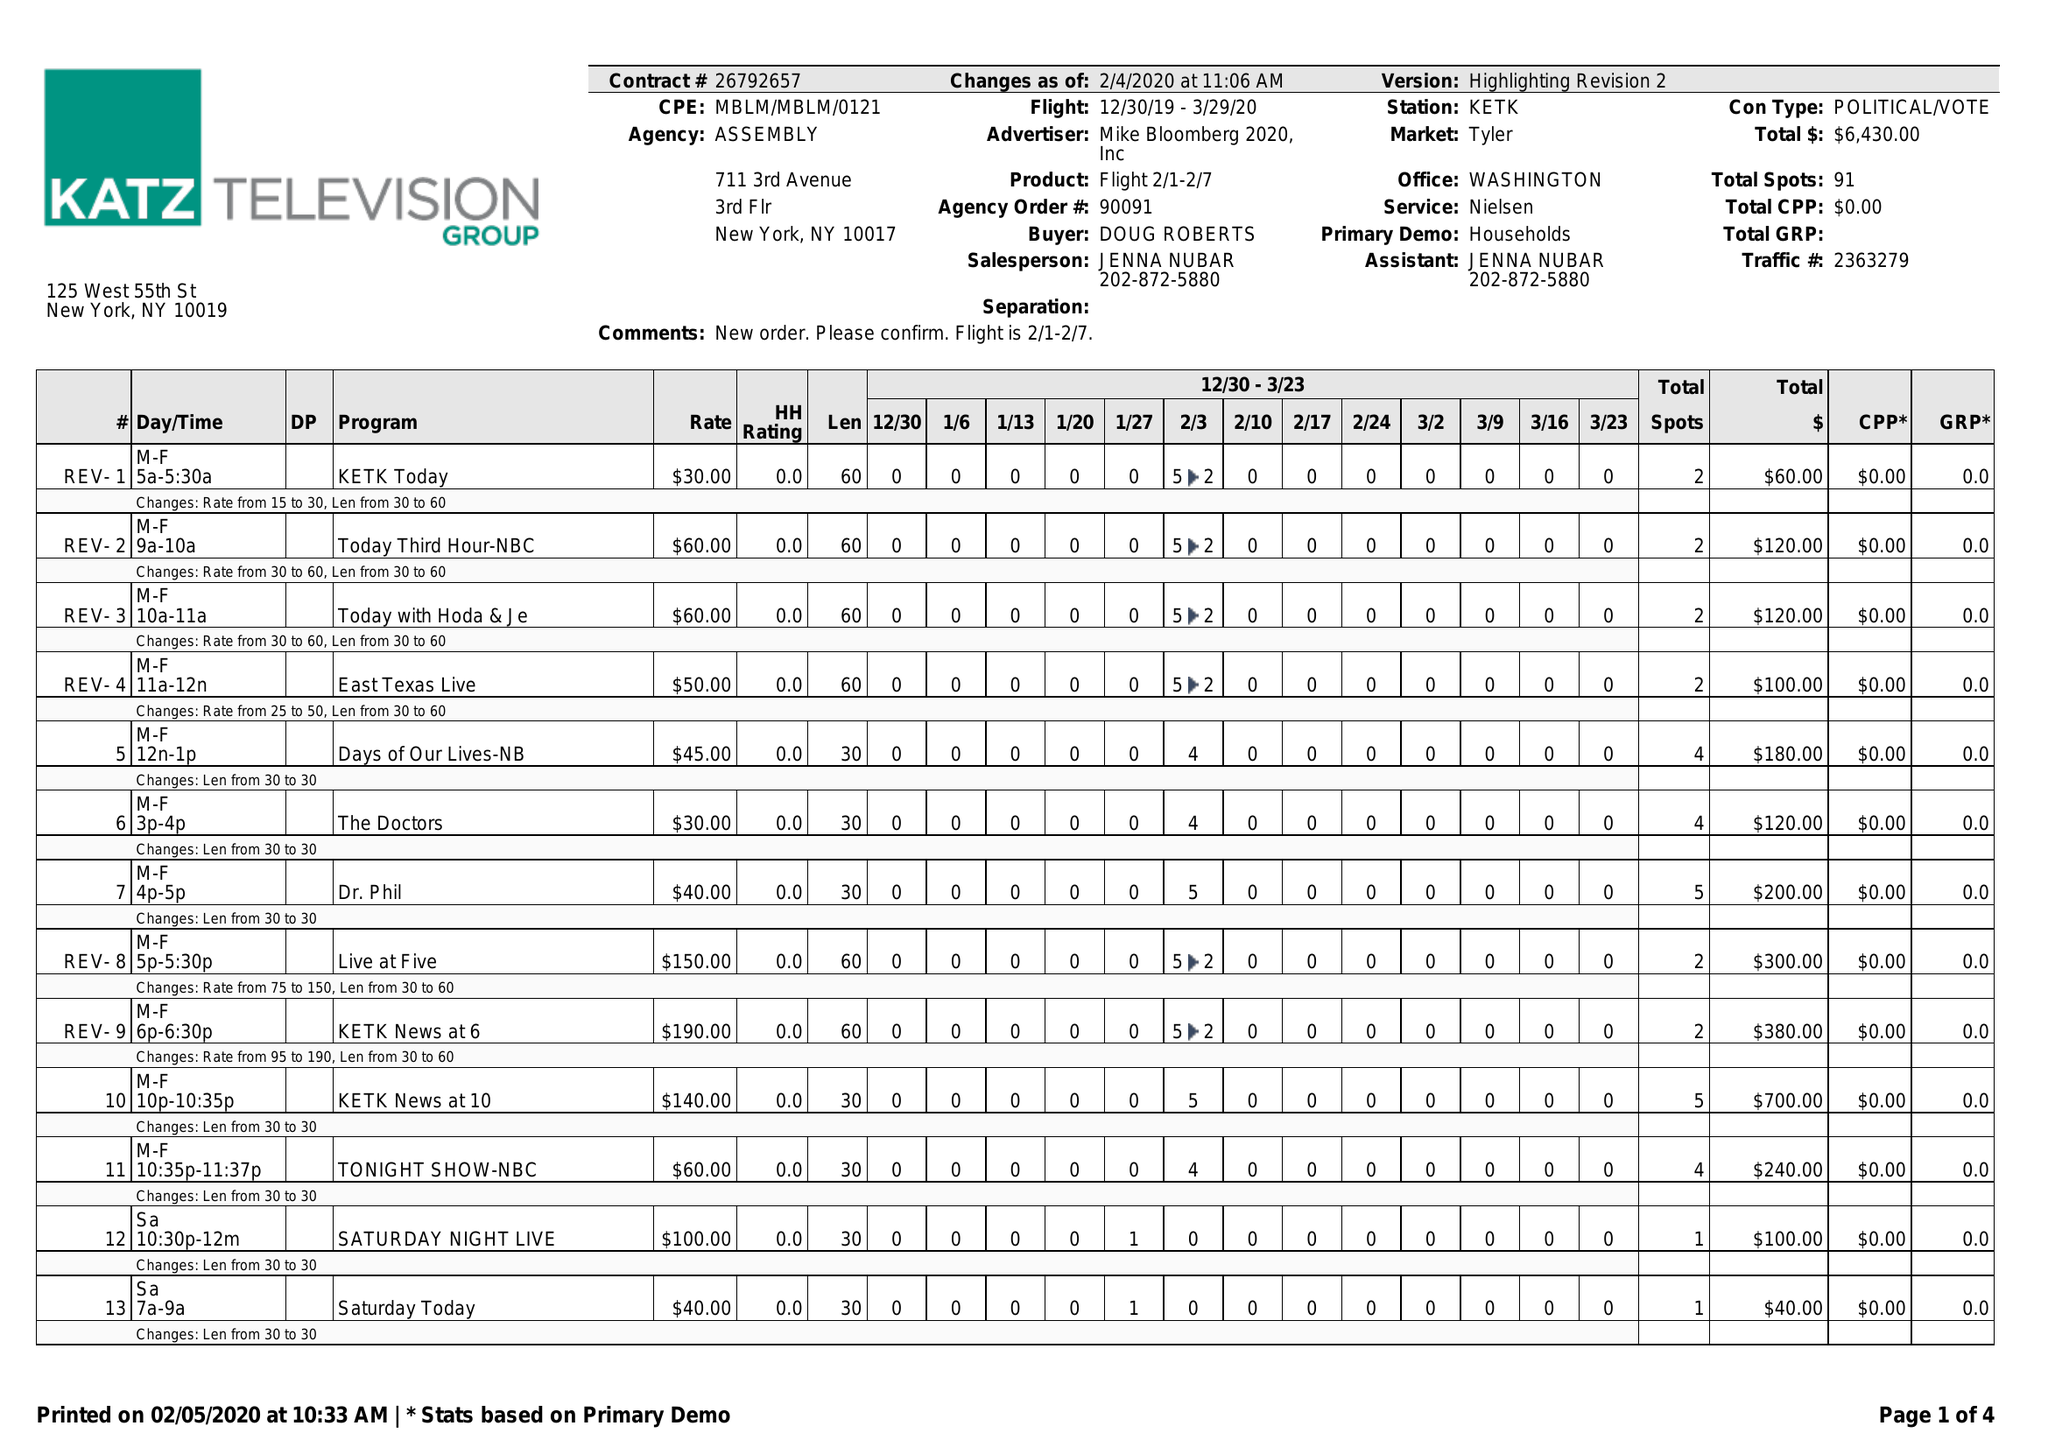What is the value for the flight_from?
Answer the question using a single word or phrase. 12/30/19 